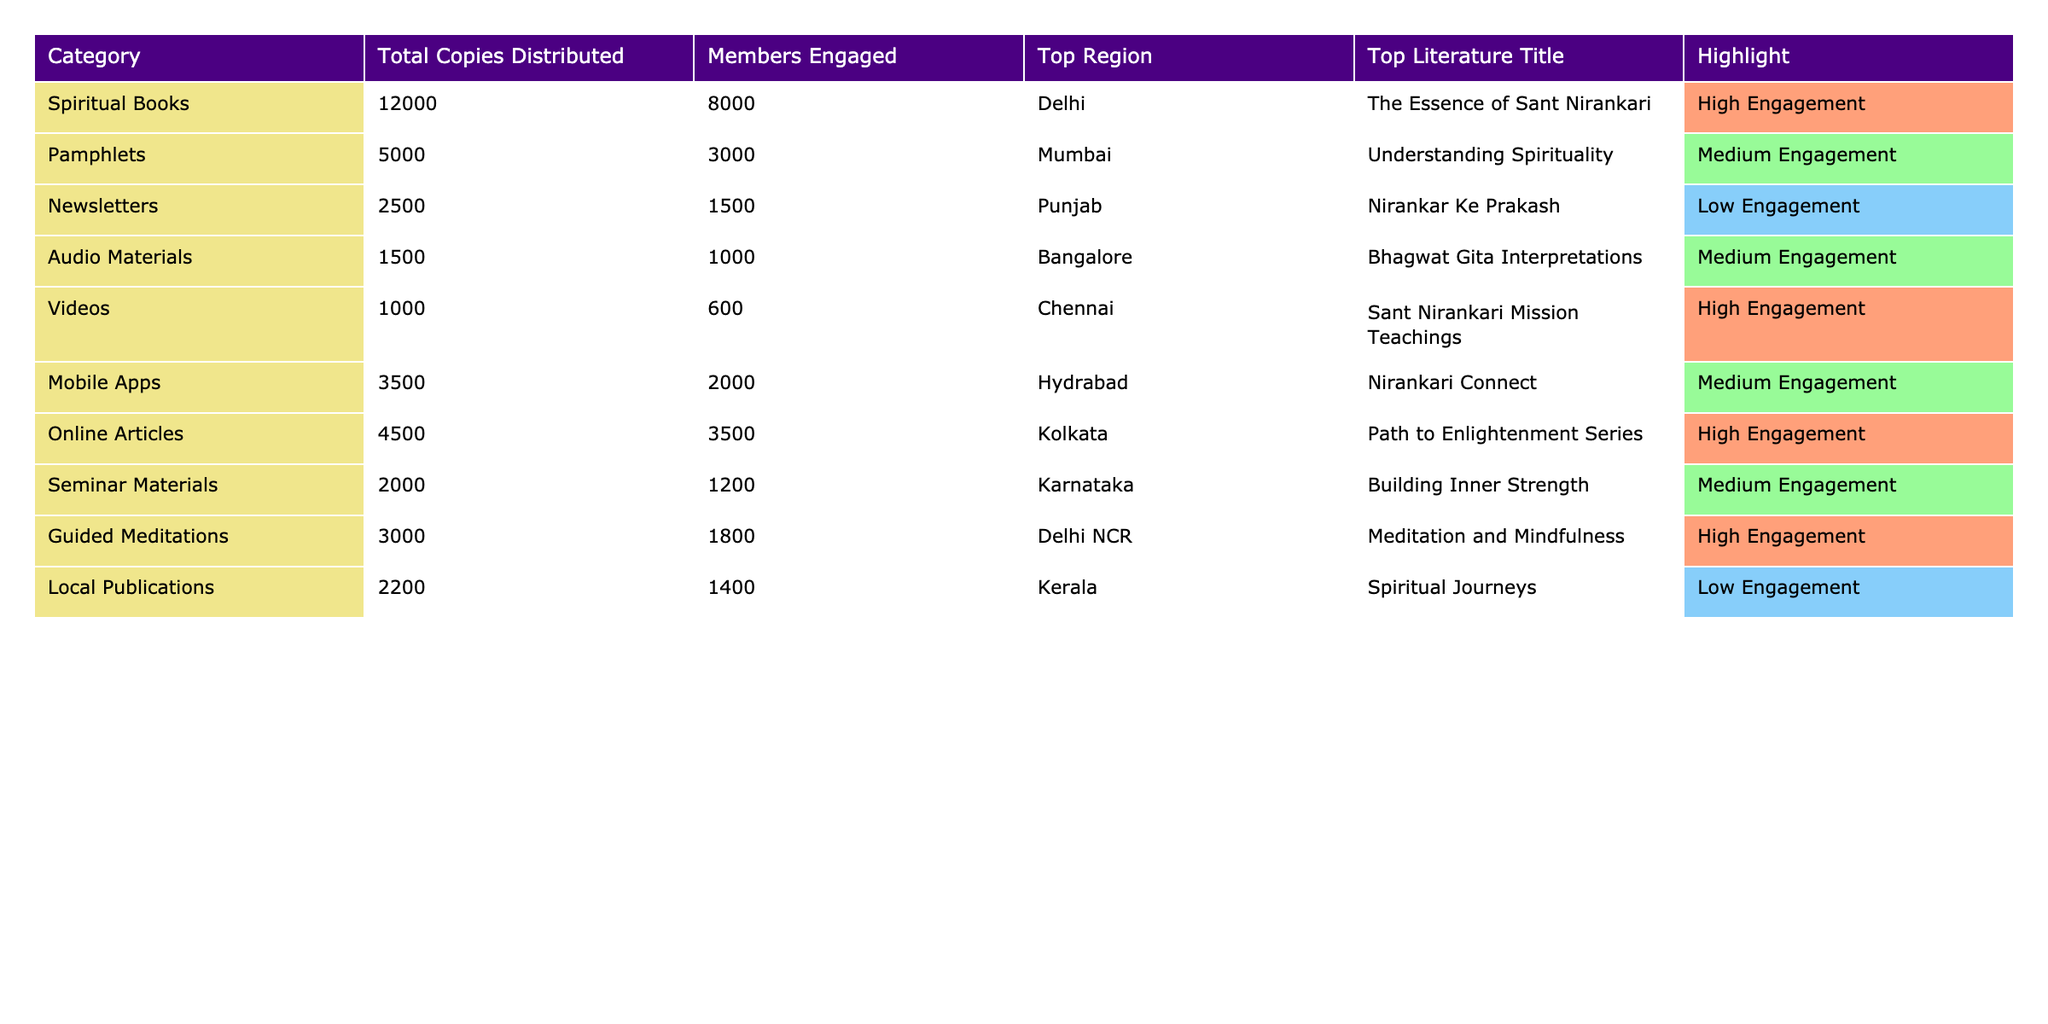What's the total number of spiritual books distributed? The table shows that the total copies of spiritual books distributed are listed under the 'Total Copies Distributed' column. That value is 12000.
Answer: 12000 Which category had the highest number of members engaged? By comparing the 'Members Engaged' column, spiritual books have the highest number with 8000 members engaged.
Answer: 8000 What is the top region for pamphlet distribution? The 'Top Region' column indicates Mumbai is the top region for pamphlet distribution.
Answer: Mumbai How many total copies are distributed across all categories? To find the total, I sum the figures from the 'Total Copies Distributed' column: 12000 + 5000 + 2500 + 1500 + 1000 + 3500 + 4500 + 2000 + 3000 + 2200 = 28000.
Answer: 28000 Is "The Essence of Sant Nirankari" the top literature title for any category? Yes, it is listed as the top literature title for spiritual books, which is confirmed by the 'Top Literature Title' column.
Answer: Yes What is the average number of copies distributed for all categories? To find the average, I calculate the total copies (28000) and divide by the number of categories (10), which gives 2800.
Answer: 2800 Which category has the lowest engagement level, and what is that engagement level? By analyzing the 'Highlight' column, newsletters and local publications both show "Low Engagement," making them the lowest.
Answer: Newsletters and local publications; Low Engagement What was the total number of guided meditations distributed compared to audio materials? Guided meditations distributed totaled 3000, while audio materials had 1500; combined they equal 4500, so guided meditations were distributed twice as much as audio materials.
Answer: Guided meditations: 3000; Audio materials: 1500 What percentage of total copies distributed were pamphlets? The percentage is calculated as (5000 / 28000) * 100, resulting in approximately 17.86%.
Answer: 17.86% In which category is the literature title "Path to Enlightenment Series" found? "Path to Enlightenment Series" is listed under the category of online articles.
Answer: Online Articles 